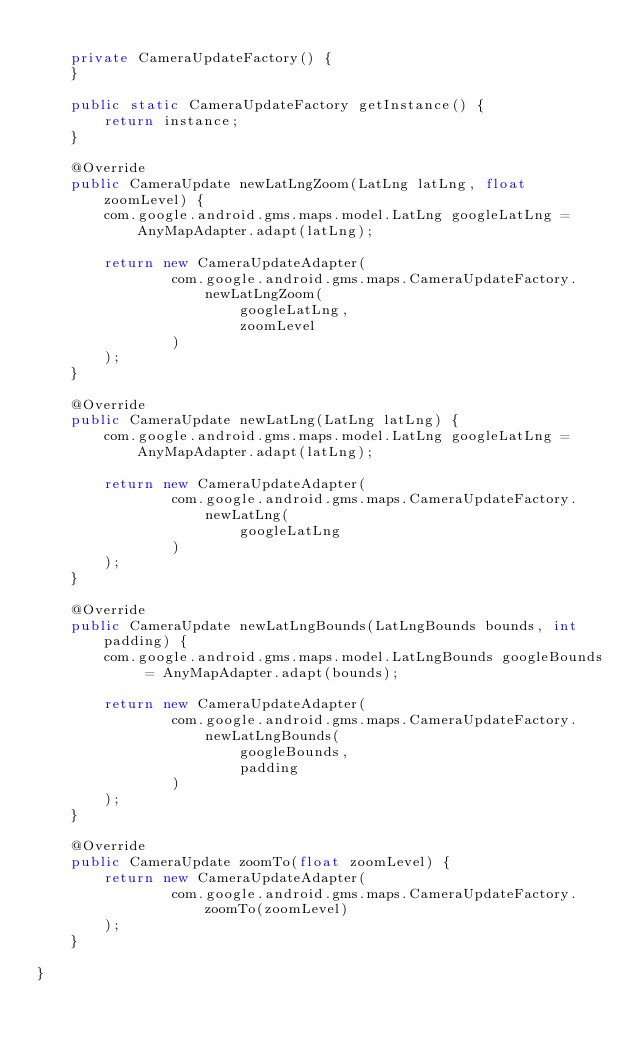Convert code to text. <code><loc_0><loc_0><loc_500><loc_500><_Java_>
	private CameraUpdateFactory() {
	}

	public static CameraUpdateFactory getInstance() {
		return instance;
	}

	@Override
	public CameraUpdate newLatLngZoom(LatLng latLng, float zoomLevel) {
		com.google.android.gms.maps.model.LatLng googleLatLng = AnyMapAdapter.adapt(latLng);

		return new CameraUpdateAdapter(
				com.google.android.gms.maps.CameraUpdateFactory.newLatLngZoom(
						googleLatLng,
						zoomLevel
				)
		);
	}

	@Override
	public CameraUpdate newLatLng(LatLng latLng) {
		com.google.android.gms.maps.model.LatLng googleLatLng = AnyMapAdapter.adapt(latLng);

		return new CameraUpdateAdapter(
				com.google.android.gms.maps.CameraUpdateFactory.newLatLng(
						googleLatLng
				)
		);
	}

	@Override
	public CameraUpdate newLatLngBounds(LatLngBounds bounds, int padding) {
		com.google.android.gms.maps.model.LatLngBounds googleBounds = AnyMapAdapter.adapt(bounds);

		return new CameraUpdateAdapter(
				com.google.android.gms.maps.CameraUpdateFactory.newLatLngBounds(
						googleBounds,
						padding
				)
		);
	}

	@Override
	public CameraUpdate zoomTo(float zoomLevel) {
		return new CameraUpdateAdapter(
				com.google.android.gms.maps.CameraUpdateFactory.zoomTo(zoomLevel)
		);
	}

}
</code> 